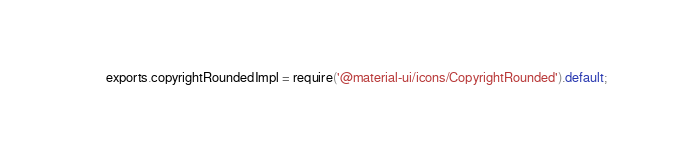<code> <loc_0><loc_0><loc_500><loc_500><_JavaScript_>exports.copyrightRoundedImpl = require('@material-ui/icons/CopyrightRounded').default;
</code> 